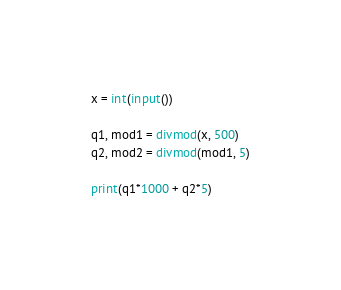<code> <loc_0><loc_0><loc_500><loc_500><_Python_>x = int(input())

q1, mod1 = divmod(x, 500)
q2, mod2 = divmod(mod1, 5)

print(q1*1000 + q2*5)</code> 